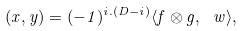Convert formula to latex. <formula><loc_0><loc_0><loc_500><loc_500>( x , y ) = ( - 1 ) ^ { i . ( D - i ) } \langle f \otimes g , \ w \rangle ,</formula> 